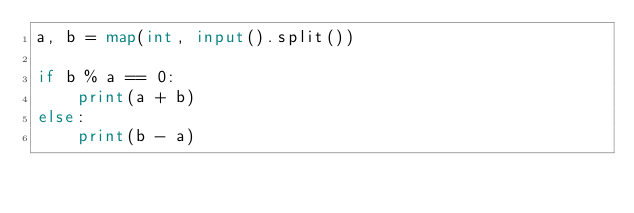<code> <loc_0><loc_0><loc_500><loc_500><_Python_>a, b = map(int, input().split())

if b % a == 0:
    print(a + b)
else:
    print(b - a)</code> 